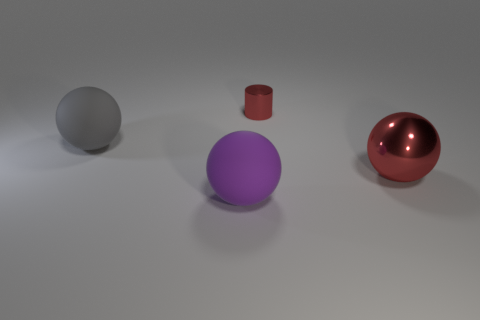There is a ball that is on the right side of the cylinder; what color is it? The ball on the right side of the cylinder is a rich, glossy red, akin to the color of ripe cherries or a classic sports car finish. 